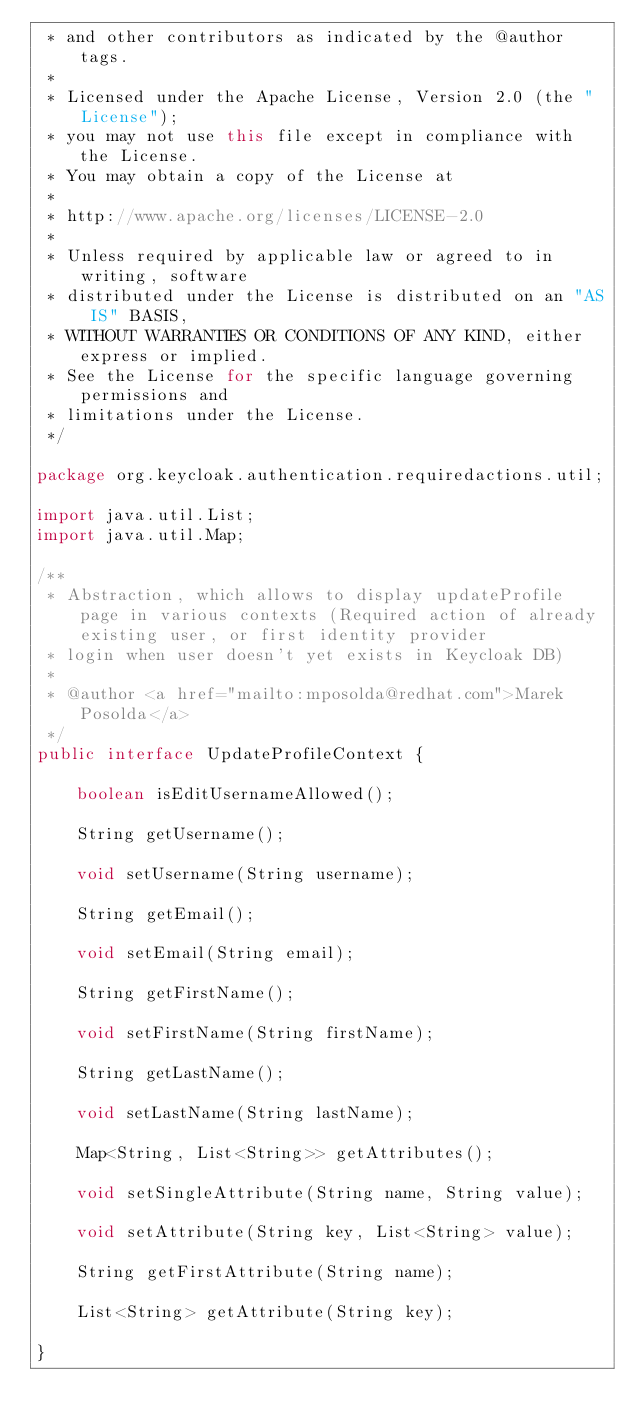<code> <loc_0><loc_0><loc_500><loc_500><_Java_> * and other contributors as indicated by the @author tags.
 *
 * Licensed under the Apache License, Version 2.0 (the "License");
 * you may not use this file except in compliance with the License.
 * You may obtain a copy of the License at
 *
 * http://www.apache.org/licenses/LICENSE-2.0
 *
 * Unless required by applicable law or agreed to in writing, software
 * distributed under the License is distributed on an "AS IS" BASIS,
 * WITHOUT WARRANTIES OR CONDITIONS OF ANY KIND, either express or implied.
 * See the License for the specific language governing permissions and
 * limitations under the License.
 */

package org.keycloak.authentication.requiredactions.util;

import java.util.List;
import java.util.Map;

/**
 * Abstraction, which allows to display updateProfile page in various contexts (Required action of already existing user, or first identity provider
 * login when user doesn't yet exists in Keycloak DB)
 *
 * @author <a href="mailto:mposolda@redhat.com">Marek Posolda</a>
 */
public interface UpdateProfileContext {

    boolean isEditUsernameAllowed();

    String getUsername();

    void setUsername(String username);

    String getEmail();

    void setEmail(String email);

    String getFirstName();

    void setFirstName(String firstName);

    String getLastName();

    void setLastName(String lastName);

    Map<String, List<String>> getAttributes();

    void setSingleAttribute(String name, String value);

    void setAttribute(String key, List<String> value);

    String getFirstAttribute(String name);

    List<String> getAttribute(String key);

}
</code> 